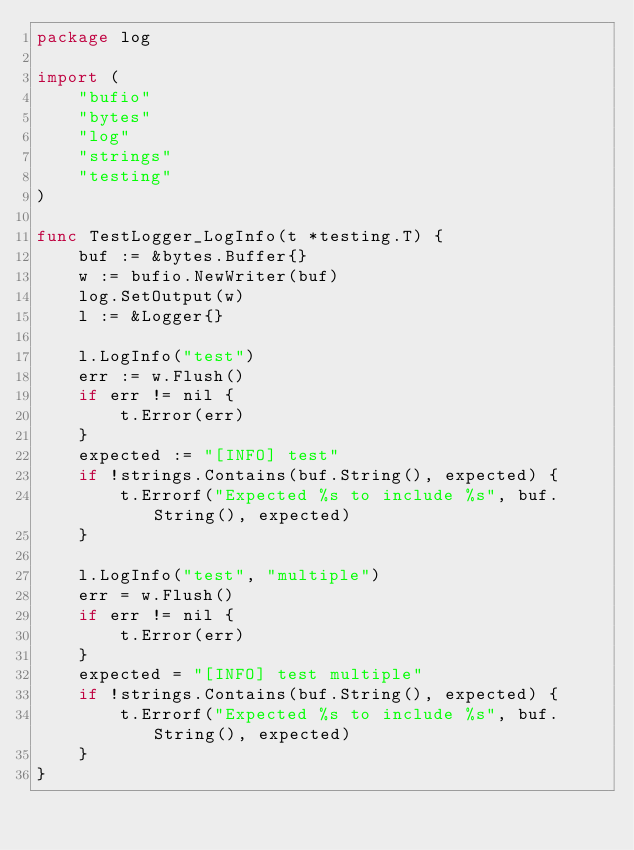<code> <loc_0><loc_0><loc_500><loc_500><_Go_>package log

import (
	"bufio"
	"bytes"
	"log"
	"strings"
	"testing"
)

func TestLogger_LogInfo(t *testing.T) {
	buf := &bytes.Buffer{}
	w := bufio.NewWriter(buf)
	log.SetOutput(w)
	l := &Logger{}

	l.LogInfo("test")
	err := w.Flush()
	if err != nil {
		t.Error(err)
	}
	expected := "[INFO] test"
	if !strings.Contains(buf.String(), expected) {
		t.Errorf("Expected %s to include %s", buf.String(), expected)
	}

	l.LogInfo("test", "multiple")
	err = w.Flush()
	if err != nil {
		t.Error(err)
	}
	expected = "[INFO] test multiple"
	if !strings.Contains(buf.String(), expected) {
		t.Errorf("Expected %s to include %s", buf.String(), expected)
	}
}
</code> 